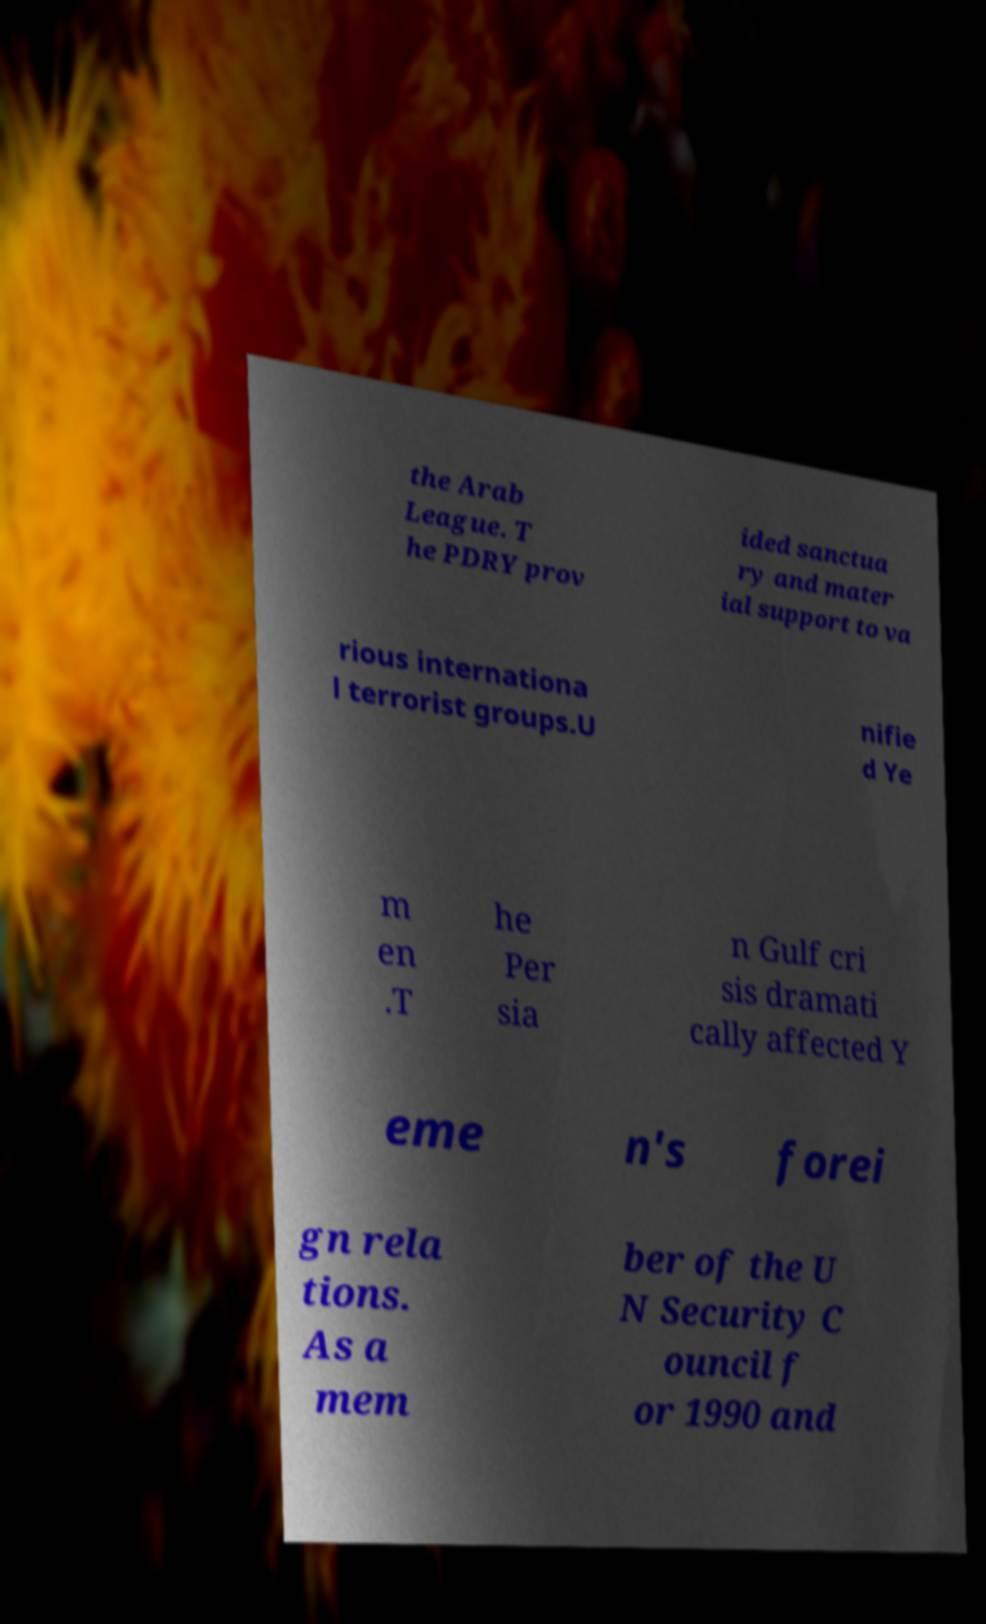Please identify and transcribe the text found in this image. the Arab League. T he PDRY prov ided sanctua ry and mater ial support to va rious internationa l terrorist groups.U nifie d Ye m en .T he Per sia n Gulf cri sis dramati cally affected Y eme n's forei gn rela tions. As a mem ber of the U N Security C ouncil f or 1990 and 